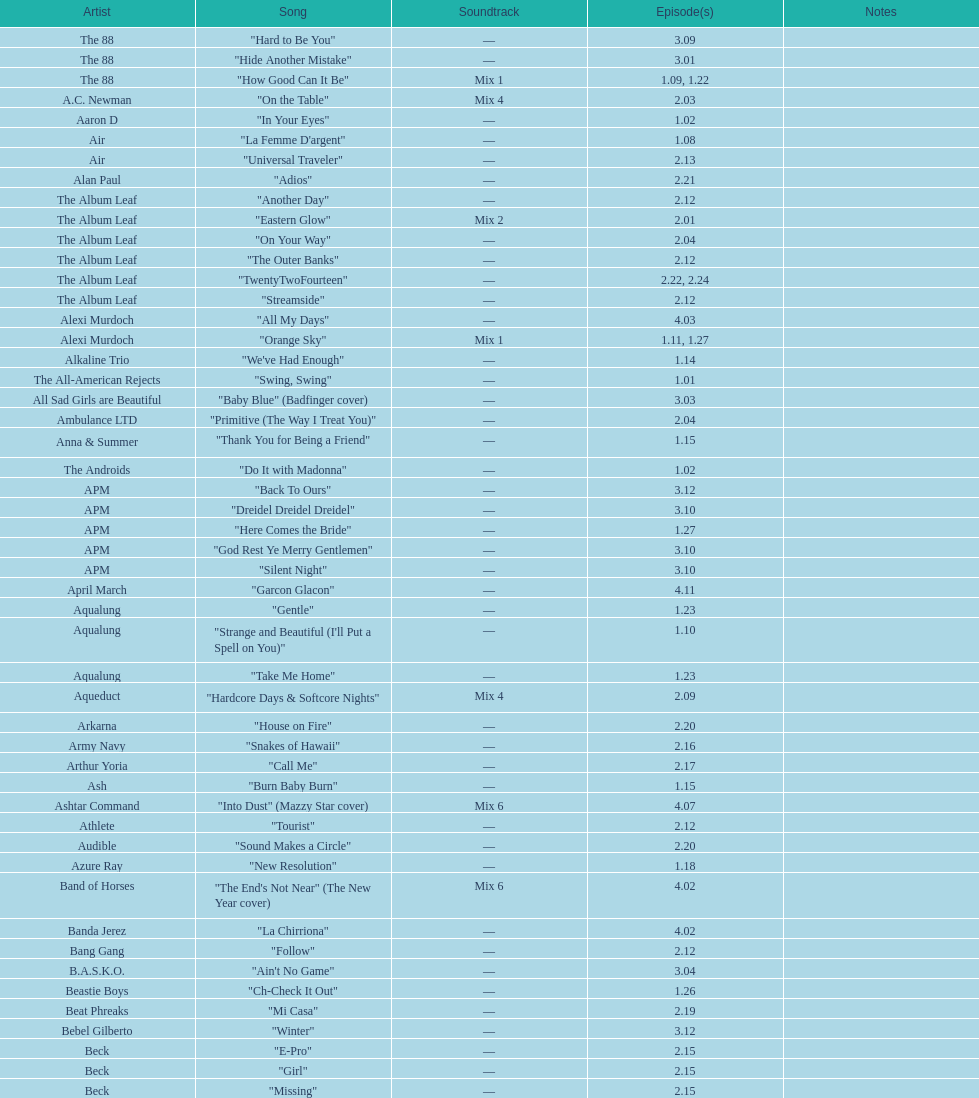What is the title of the single song by the artist ash that was featured in the o.c.? "Burn Baby Burn". 